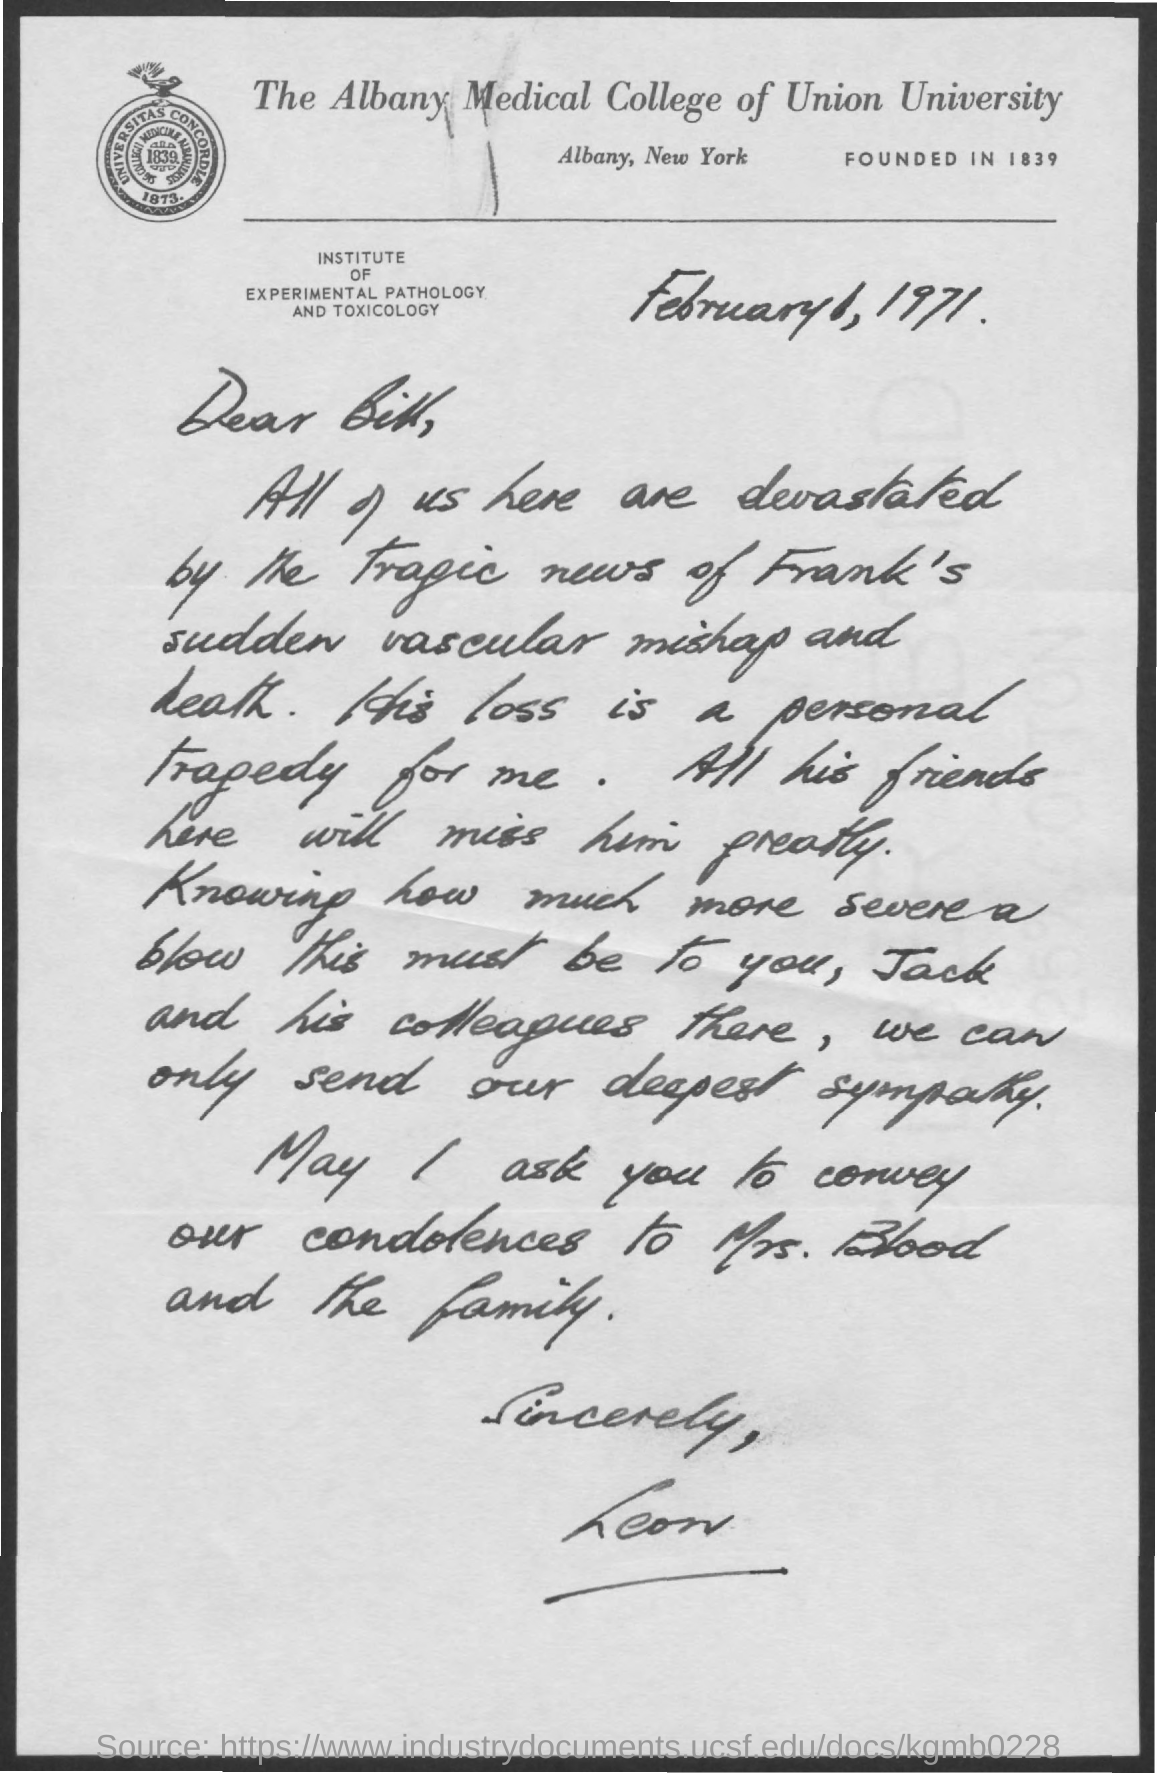Identify some key points in this picture. On February 6, 1971, a letter was written. The letter head mentions The Albany Medical College of Union University. The Albany Medical College of Union University was founded in 1839. The addressee of this letter is Bill. The sender of this letter is Leon. 